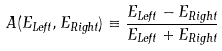Convert formula to latex. <formula><loc_0><loc_0><loc_500><loc_500>A ( E _ { L e f t } , E _ { R i g h t } ) \equiv \frac { E _ { L e f t } - E _ { R i g h t } } { E _ { L e f t } + E _ { R i g h t } }</formula> 